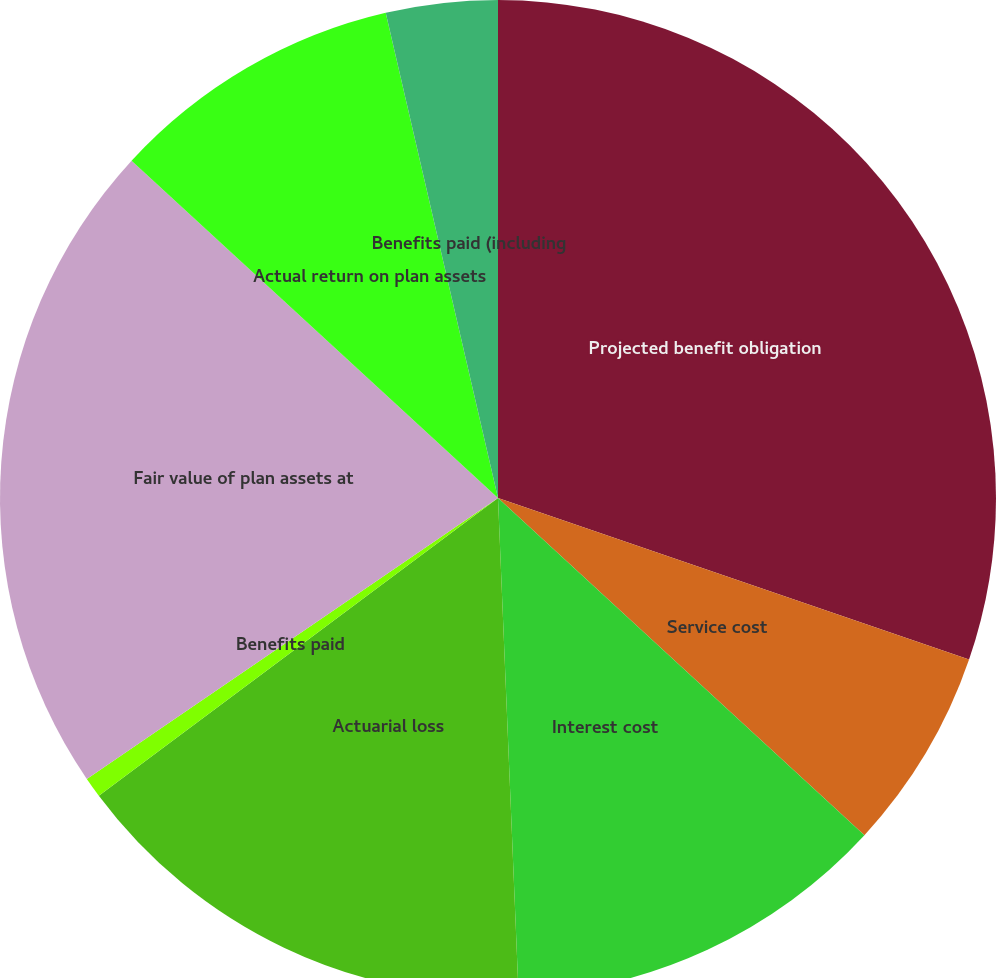Convert chart. <chart><loc_0><loc_0><loc_500><loc_500><pie_chart><fcel>Projected benefit obligation<fcel>Service cost<fcel>Interest cost<fcel>Actuarial loss<fcel>Benefits paid<fcel>Fair value of plan assets at<fcel>Actual return on plan assets<fcel>Benefits paid (including<nl><fcel>30.26%<fcel>6.58%<fcel>12.5%<fcel>15.46%<fcel>0.66%<fcel>21.38%<fcel>9.54%<fcel>3.62%<nl></chart> 